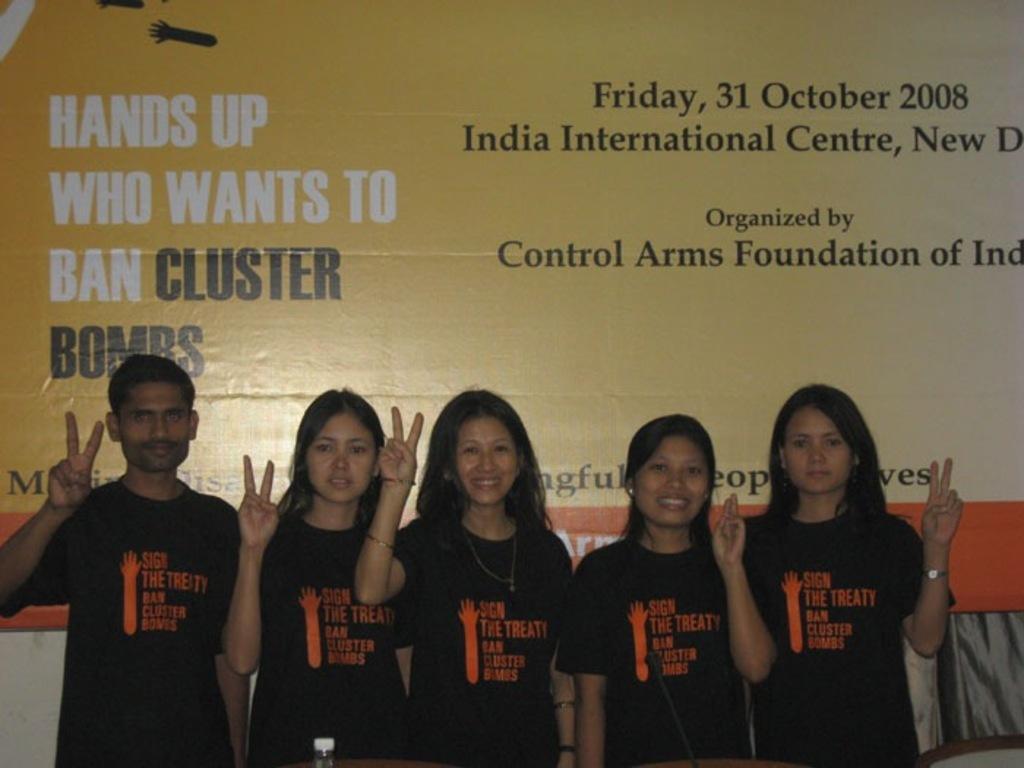In one or two sentences, can you explain what this image depicts? In this image we can see five persons and on the person's shirt we can see some text. Behind the persons we can see a wall and a banner with text. 